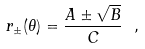<formula> <loc_0><loc_0><loc_500><loc_500>r _ { \pm } ( \theta ) = \frac { A \pm \sqrt { B } } { C } \ ,</formula> 